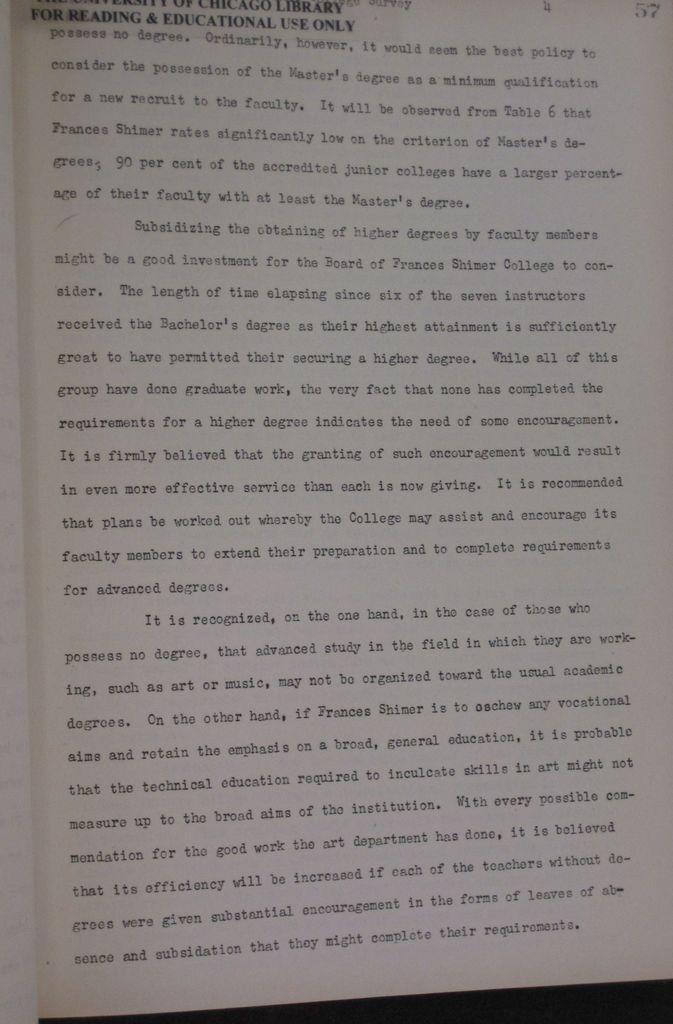<image>
Present a compact description of the photo's key features. A paper for reading and education use only 